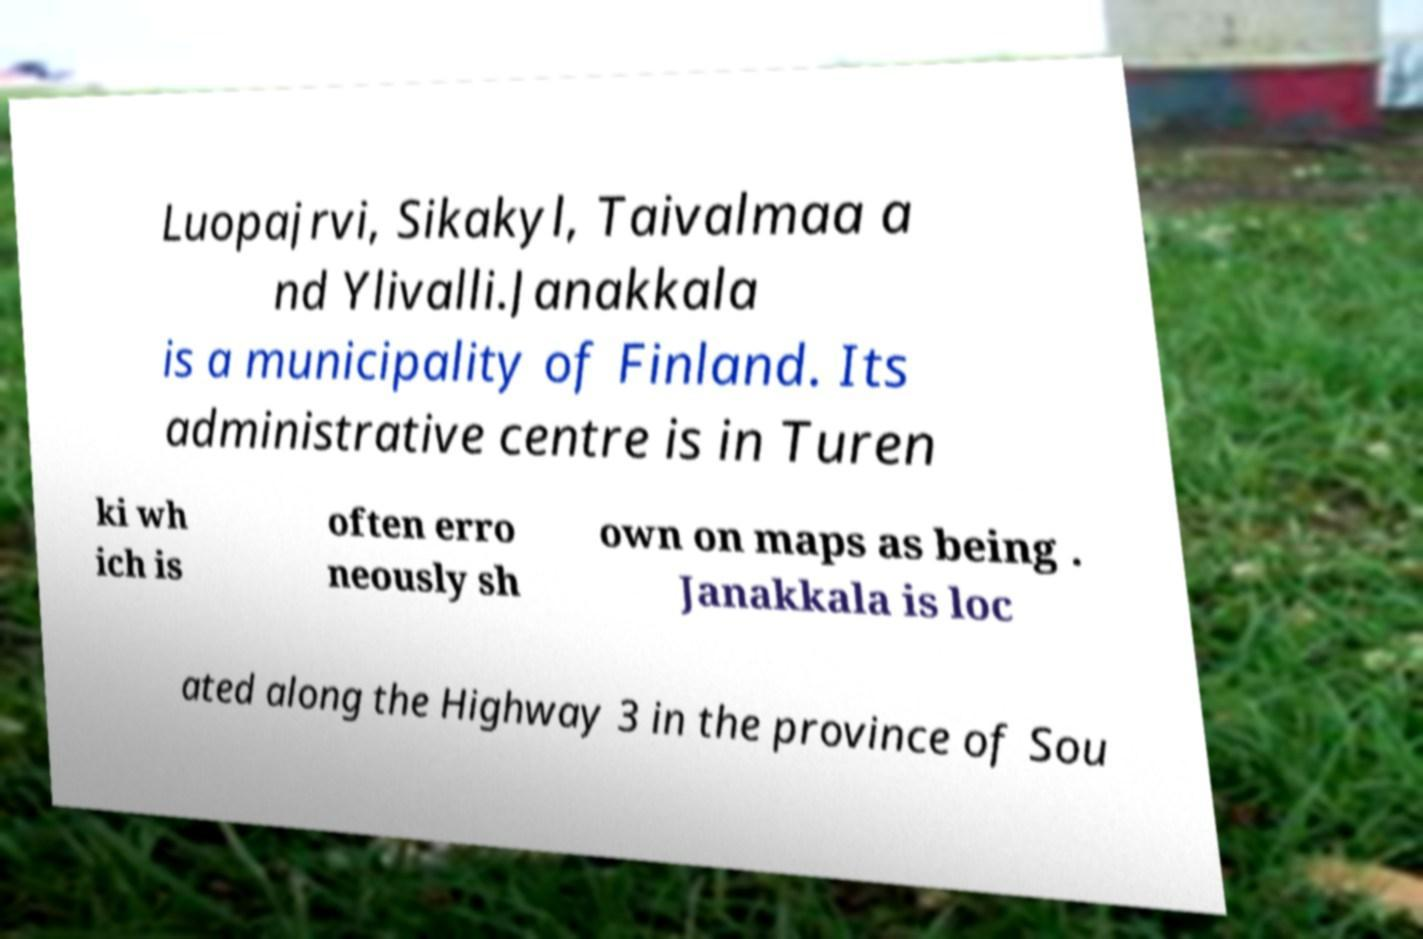Could you extract and type out the text from this image? Luopajrvi, Sikakyl, Taivalmaa a nd Ylivalli.Janakkala is a municipality of Finland. Its administrative centre is in Turen ki wh ich is often erro neously sh own on maps as being . Janakkala is loc ated along the Highway 3 in the province of Sou 